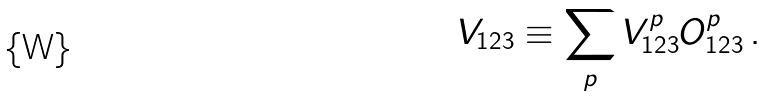<formula> <loc_0><loc_0><loc_500><loc_500>V _ { 1 2 3 } \equiv \sum _ { p } V _ { 1 2 3 } ^ { p } { O } _ { 1 2 3 } ^ { p } \, .</formula> 